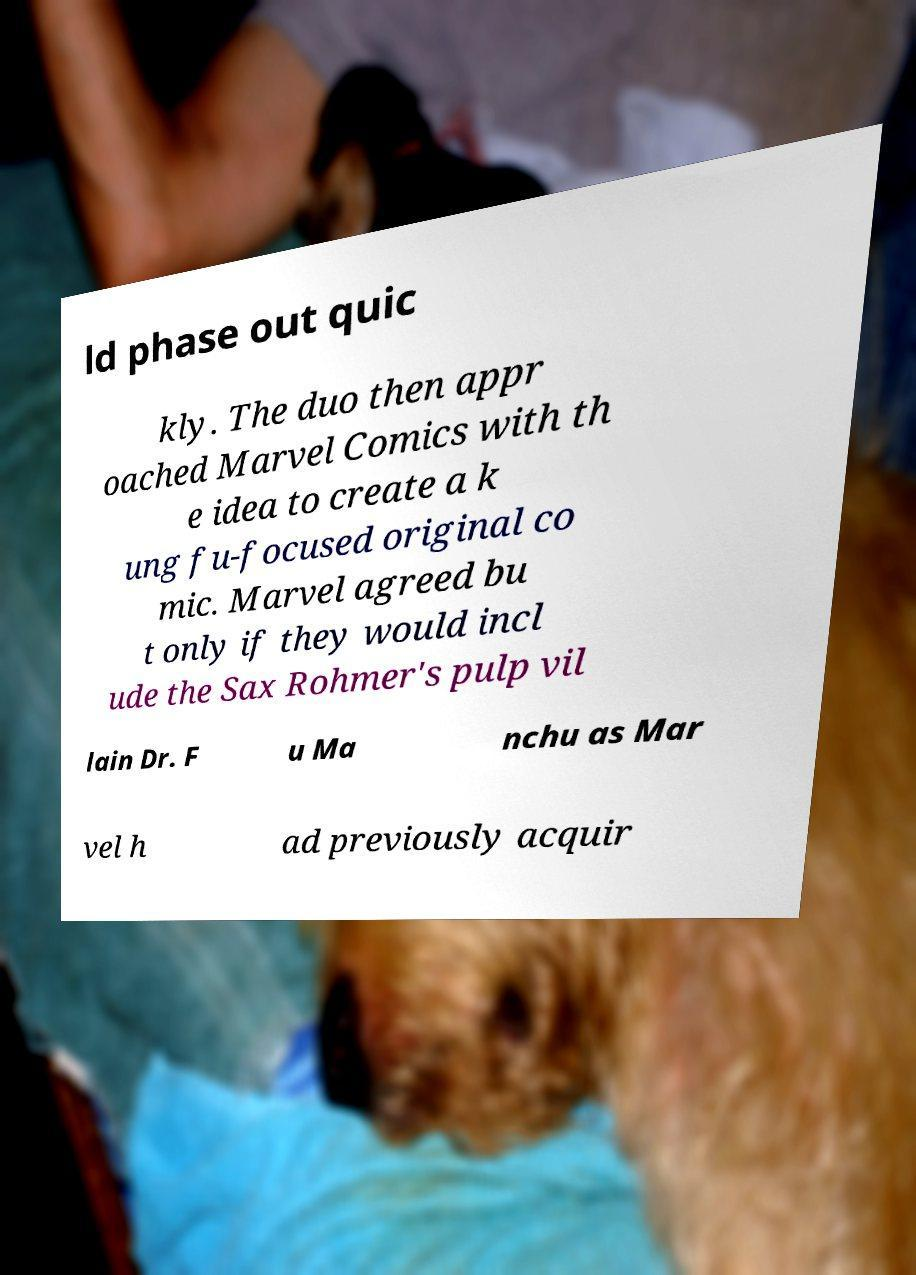Could you extract and type out the text from this image? ld phase out quic kly. The duo then appr oached Marvel Comics with th e idea to create a k ung fu-focused original co mic. Marvel agreed bu t only if they would incl ude the Sax Rohmer's pulp vil lain Dr. F u Ma nchu as Mar vel h ad previously acquir 